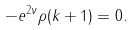Convert formula to latex. <formula><loc_0><loc_0><loc_500><loc_500>- e ^ { 2 \nu } \rho ( k + 1 ) = 0 .</formula> 